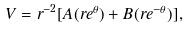<formula> <loc_0><loc_0><loc_500><loc_500>V = r ^ { - 2 } [ A ( r e ^ { \theta } ) + B ( r e ^ { - \theta } ) ] ,</formula> 